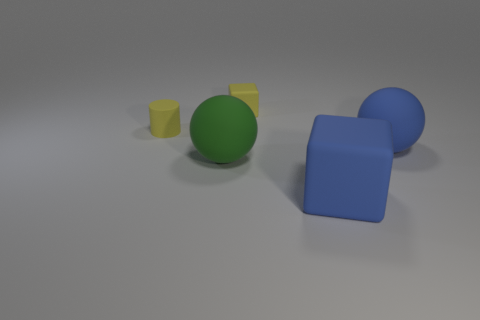Subtract all yellow balls. Subtract all gray blocks. How many balls are left? 2 Add 5 tiny green balls. How many objects exist? 10 Subtract all spheres. How many objects are left? 3 Subtract all tiny gray cylinders. Subtract all yellow rubber things. How many objects are left? 3 Add 4 big blue things. How many big blue things are left? 6 Add 1 big blocks. How many big blocks exist? 2 Subtract 0 purple spheres. How many objects are left? 5 